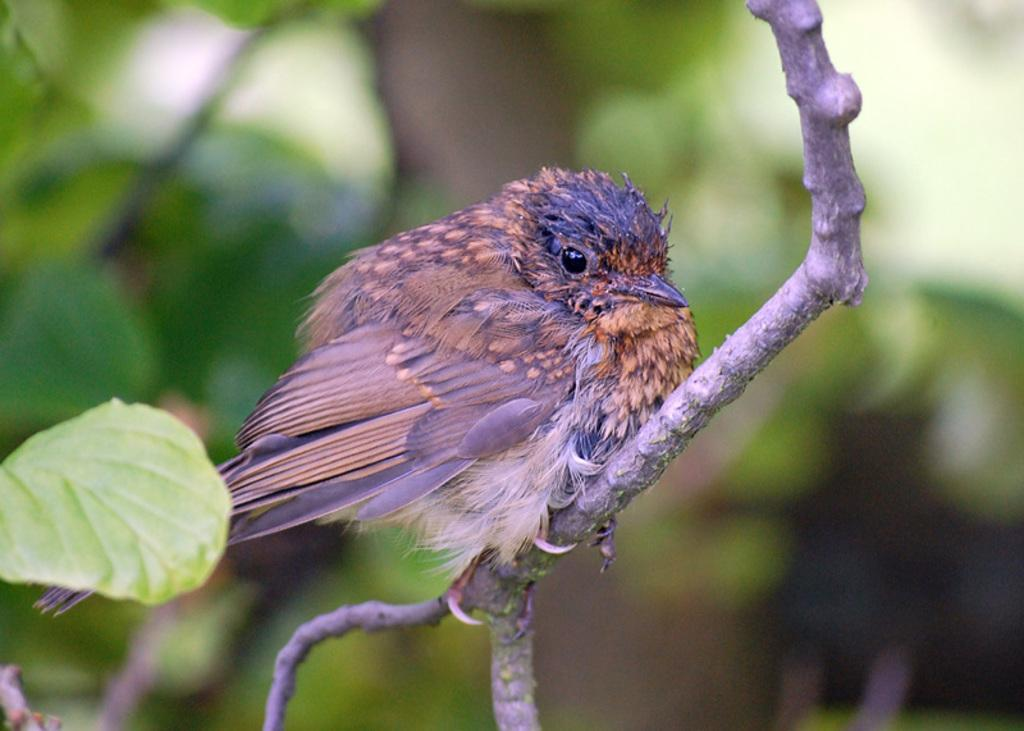What type of animal can be seen in the image? There is a bird in the image. Where is the bird located? The bird is sitting on a branch. What is the branch a part of? The branch is part of a tree. What is the appearance of the tree's leaves? The tree has green leaves. Where are the boys eating lunch in the image? There are no boys or lunchroom present in the image; it features a bird sitting on a branch of a tree with green leaves. What type of doll is sitting on the tree branch in the image? There is no doll present in the image; it features a bird sitting on a branch of a tree with green leaves. 